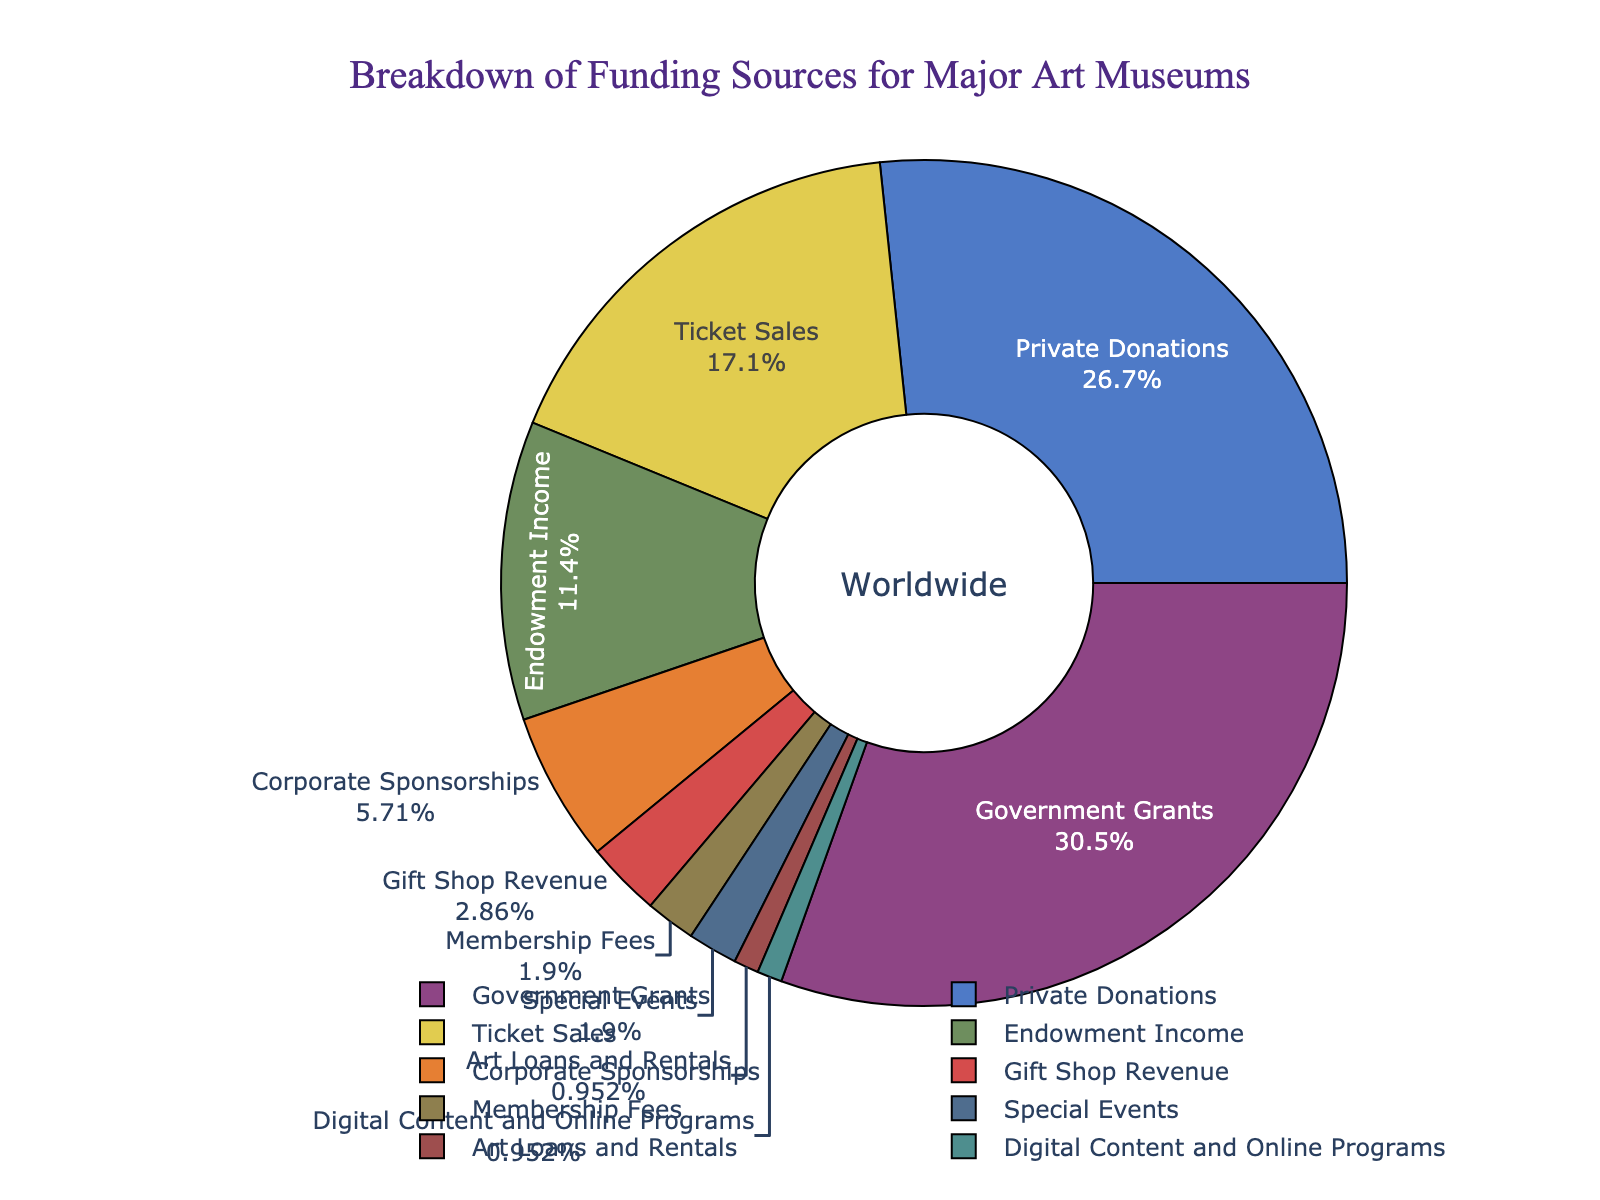What's the main funding source for major art museums? By looking at the pie chart, we observe which segment has the largest slice. The largest segment in the pie chart is labeled "Government Grants" with 32%.
Answer: Government Grants How much more percentage do private donations contribute compared to ticket sales? Private donations contribute 28% and ticket sales contribute 18%. To find the difference, we subtract 18% from 28%. Therefore, 28% - 18% = 10%.
Answer: 10% What is the combined percentage of corporate sponsorships, gift shop revenue, membership fees, and special events? First, sum the percentages of corporate sponsorships (6%), gift shop revenue (3%), membership fees (2%), and special events (2%). So, 6% + 3% + 2% + 2% = 13%.
Answer: 13% Which funding source has the smallest contribution, and what is its percentage? The smallest slice in the pie chart is labeled "Digital Content and Online Programs" with 1%.
Answer: Digital Content and Online Programs, 1% How much do ticket sales and endowment income contribute together? Add the percentages of ticket sales (18%) and endowment income (12%). Thus, 18% + 12% = 30%.
Answer: 30% Rank the top three funding sources in descending order. The top three funding sources are identified by looking at the largest slices in the pie chart. They are "Government Grants" with 32%, "Private Donations" with 28%, and "Ticket Sales" with 18%.
Answer: Government Grants, Private Donations, Ticket Sales What is the percentage difference between the largest and smallest funding sources? The largest funding source is "Government Grants" at 32%, and the smallest is "Digital Content and Online Programs" at 1%. The difference is 32% - 1% = 31%.
Answer: 31% Which funding sources have the same contribution, and what is their percentage? By inspecting the pie chart, "Membership Fees" and "Special Events" both contribute 2%.
Answer: Membership Fees and Special Events, 2% What percentage of funding is not covered by government grants, private donations, and ticket sales? First sum the contributions of government grants (32%), private donations (28%), and ticket sales (18%). The total is 32% + 28% + 18% = 78%. Subtract this from 100% to get the remainder: 100% - 78% = 22%.
Answer: 22% What visual indicators help distinguish each section of the pie chart? The pie chart uses different colors for each section, distinct labels, and percentages shown inside the slices. Additionally, it has a hole in the middle with "Worldwide" labeled to enhance readability.
Answer: Colors, labels, percentages, "Worldwide" annotation 